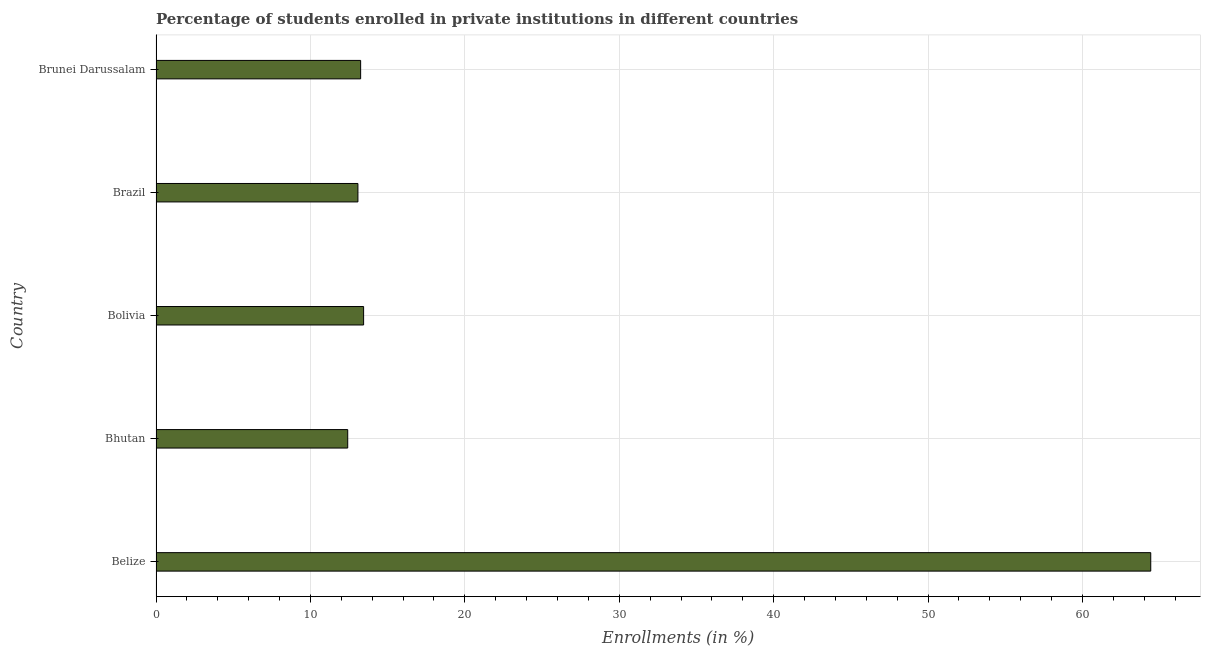Does the graph contain any zero values?
Your answer should be very brief. No. What is the title of the graph?
Keep it short and to the point. Percentage of students enrolled in private institutions in different countries. What is the label or title of the X-axis?
Offer a very short reply. Enrollments (in %). What is the label or title of the Y-axis?
Make the answer very short. Country. What is the enrollments in private institutions in Brunei Darussalam?
Make the answer very short. 13.25. Across all countries, what is the maximum enrollments in private institutions?
Provide a succinct answer. 64.42. Across all countries, what is the minimum enrollments in private institutions?
Offer a very short reply. 12.42. In which country was the enrollments in private institutions maximum?
Your response must be concise. Belize. In which country was the enrollments in private institutions minimum?
Ensure brevity in your answer.  Bhutan. What is the sum of the enrollments in private institutions?
Offer a terse response. 116.61. What is the difference between the enrollments in private institutions in Bolivia and Brazil?
Offer a terse response. 0.37. What is the average enrollments in private institutions per country?
Ensure brevity in your answer.  23.32. What is the median enrollments in private institutions?
Your answer should be very brief. 13.25. In how many countries, is the enrollments in private institutions greater than 12 %?
Your answer should be compact. 5. What is the ratio of the enrollments in private institutions in Belize to that in Bhutan?
Keep it short and to the point. 5.19. What is the difference between the highest and the second highest enrollments in private institutions?
Give a very brief answer. 50.98. What is the difference between the highest and the lowest enrollments in private institutions?
Provide a short and direct response. 52.01. Are all the bars in the graph horizontal?
Offer a terse response. Yes. How many countries are there in the graph?
Your response must be concise. 5. What is the difference between two consecutive major ticks on the X-axis?
Your response must be concise. 10. What is the Enrollments (in %) in Belize?
Offer a terse response. 64.42. What is the Enrollments (in %) in Bhutan?
Give a very brief answer. 12.42. What is the Enrollments (in %) in Bolivia?
Your answer should be compact. 13.44. What is the Enrollments (in %) of Brazil?
Offer a terse response. 13.08. What is the Enrollments (in %) of Brunei Darussalam?
Make the answer very short. 13.25. What is the difference between the Enrollments (in %) in Belize and Bhutan?
Offer a terse response. 52.01. What is the difference between the Enrollments (in %) in Belize and Bolivia?
Give a very brief answer. 50.98. What is the difference between the Enrollments (in %) in Belize and Brazil?
Provide a succinct answer. 51.35. What is the difference between the Enrollments (in %) in Belize and Brunei Darussalam?
Your answer should be compact. 51.17. What is the difference between the Enrollments (in %) in Bhutan and Bolivia?
Provide a succinct answer. -1.03. What is the difference between the Enrollments (in %) in Bhutan and Brazil?
Provide a short and direct response. -0.66. What is the difference between the Enrollments (in %) in Bhutan and Brunei Darussalam?
Provide a short and direct response. -0.84. What is the difference between the Enrollments (in %) in Bolivia and Brazil?
Your response must be concise. 0.37. What is the difference between the Enrollments (in %) in Bolivia and Brunei Darussalam?
Ensure brevity in your answer.  0.19. What is the difference between the Enrollments (in %) in Brazil and Brunei Darussalam?
Provide a succinct answer. -0.18. What is the ratio of the Enrollments (in %) in Belize to that in Bhutan?
Give a very brief answer. 5.19. What is the ratio of the Enrollments (in %) in Belize to that in Bolivia?
Ensure brevity in your answer.  4.79. What is the ratio of the Enrollments (in %) in Belize to that in Brazil?
Ensure brevity in your answer.  4.93. What is the ratio of the Enrollments (in %) in Belize to that in Brunei Darussalam?
Your answer should be very brief. 4.86. What is the ratio of the Enrollments (in %) in Bhutan to that in Bolivia?
Provide a succinct answer. 0.92. What is the ratio of the Enrollments (in %) in Bhutan to that in Brazil?
Keep it short and to the point. 0.95. What is the ratio of the Enrollments (in %) in Bhutan to that in Brunei Darussalam?
Offer a terse response. 0.94. What is the ratio of the Enrollments (in %) in Bolivia to that in Brazil?
Your response must be concise. 1.03. What is the ratio of the Enrollments (in %) in Brazil to that in Brunei Darussalam?
Your response must be concise. 0.99. 